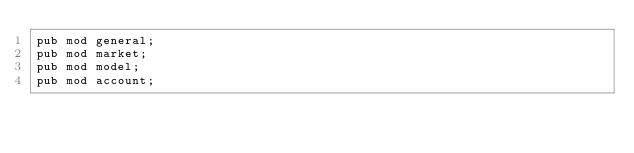<code> <loc_0><loc_0><loc_500><loc_500><_Rust_>pub mod general;
pub mod market;
pub mod model;
pub mod account;
</code> 